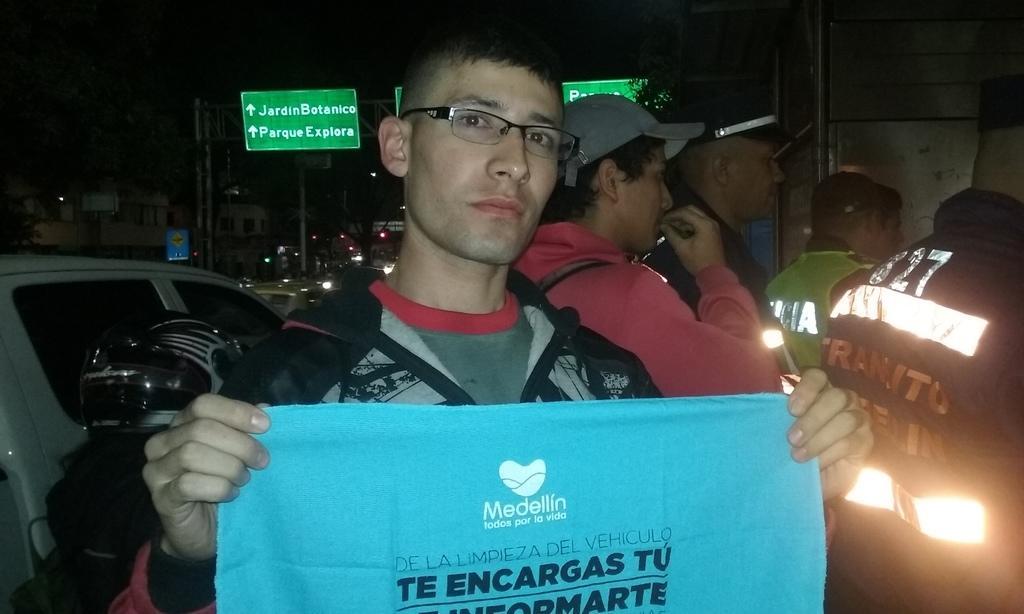Could you give a brief overview of what you see in this image? This is the picture of a road. In the foreground there is a person standing and holding the cloth, there is a text on the cloth. At the back there is a board on the pole. There are vehicles on the road. At the back there are buildings and trees. 